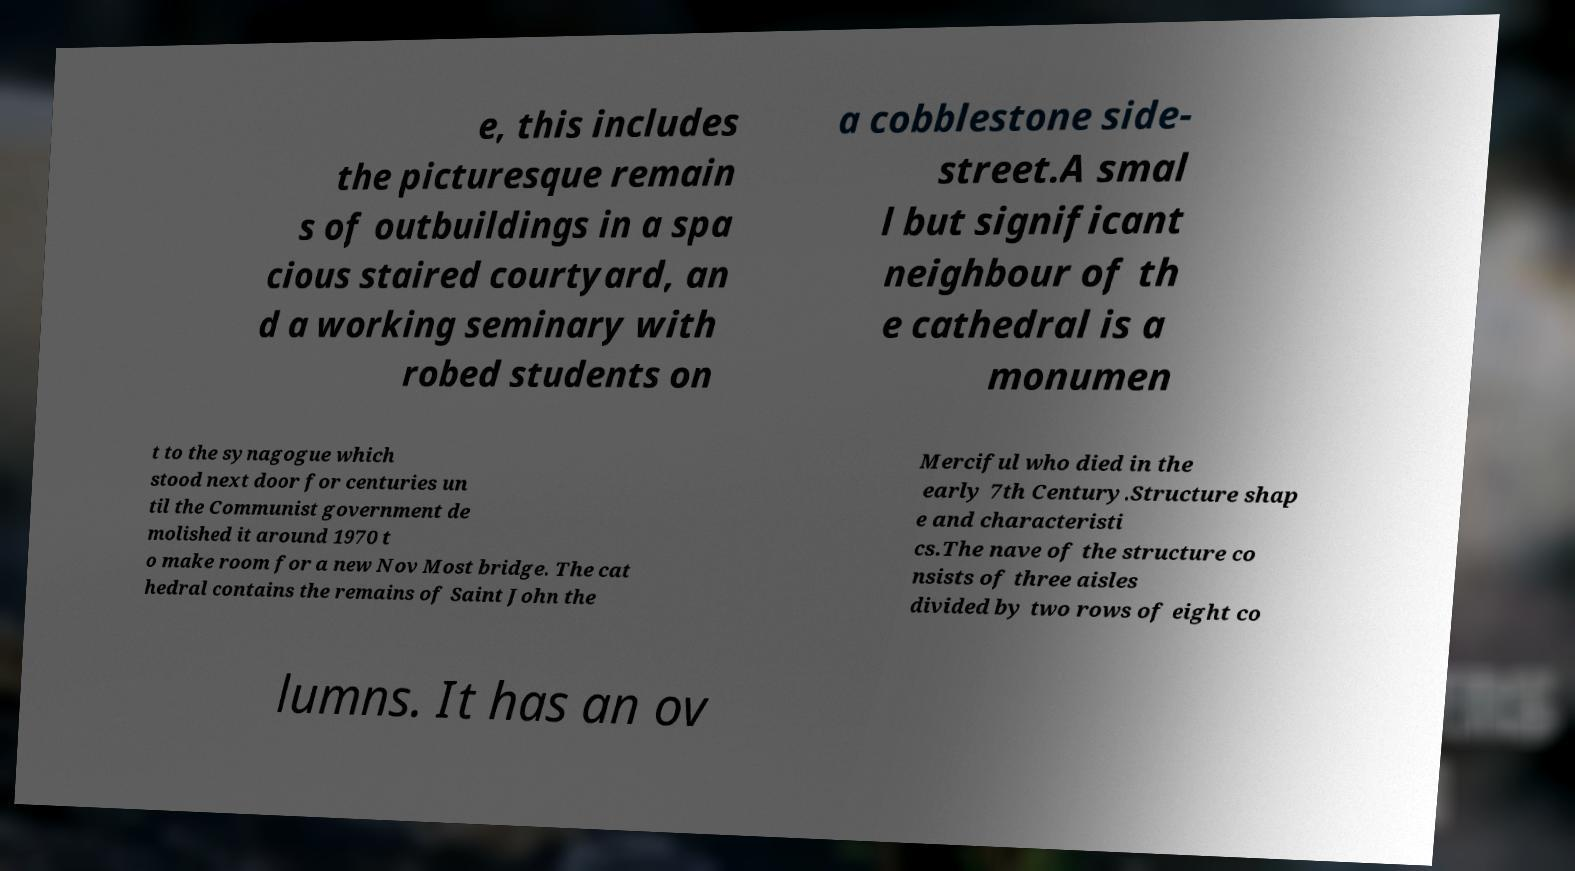Please read and relay the text visible in this image. What does it say? e, this includes the picturesque remain s of outbuildings in a spa cious staired courtyard, an d a working seminary with robed students on a cobblestone side- street.A smal l but significant neighbour of th e cathedral is a monumen t to the synagogue which stood next door for centuries un til the Communist government de molished it around 1970 t o make room for a new Nov Most bridge. The cat hedral contains the remains of Saint John the Merciful who died in the early 7th Century.Structure shap e and characteristi cs.The nave of the structure co nsists of three aisles divided by two rows of eight co lumns. It has an ov 